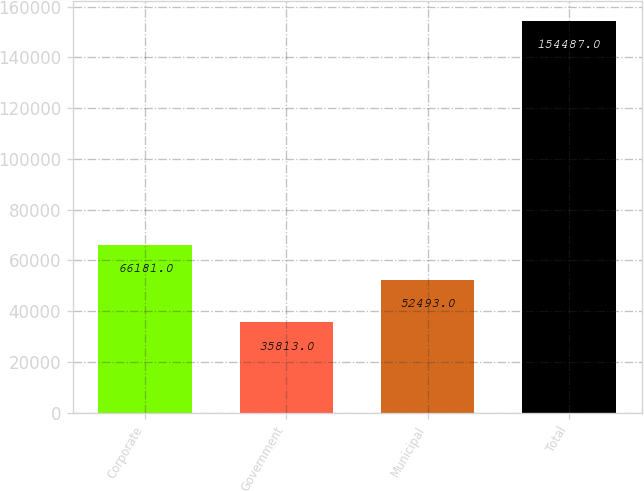<chart> <loc_0><loc_0><loc_500><loc_500><bar_chart><fcel>Corporate<fcel>Government<fcel>Municipal<fcel>Total<nl><fcel>66181<fcel>35813<fcel>52493<fcel>154487<nl></chart> 